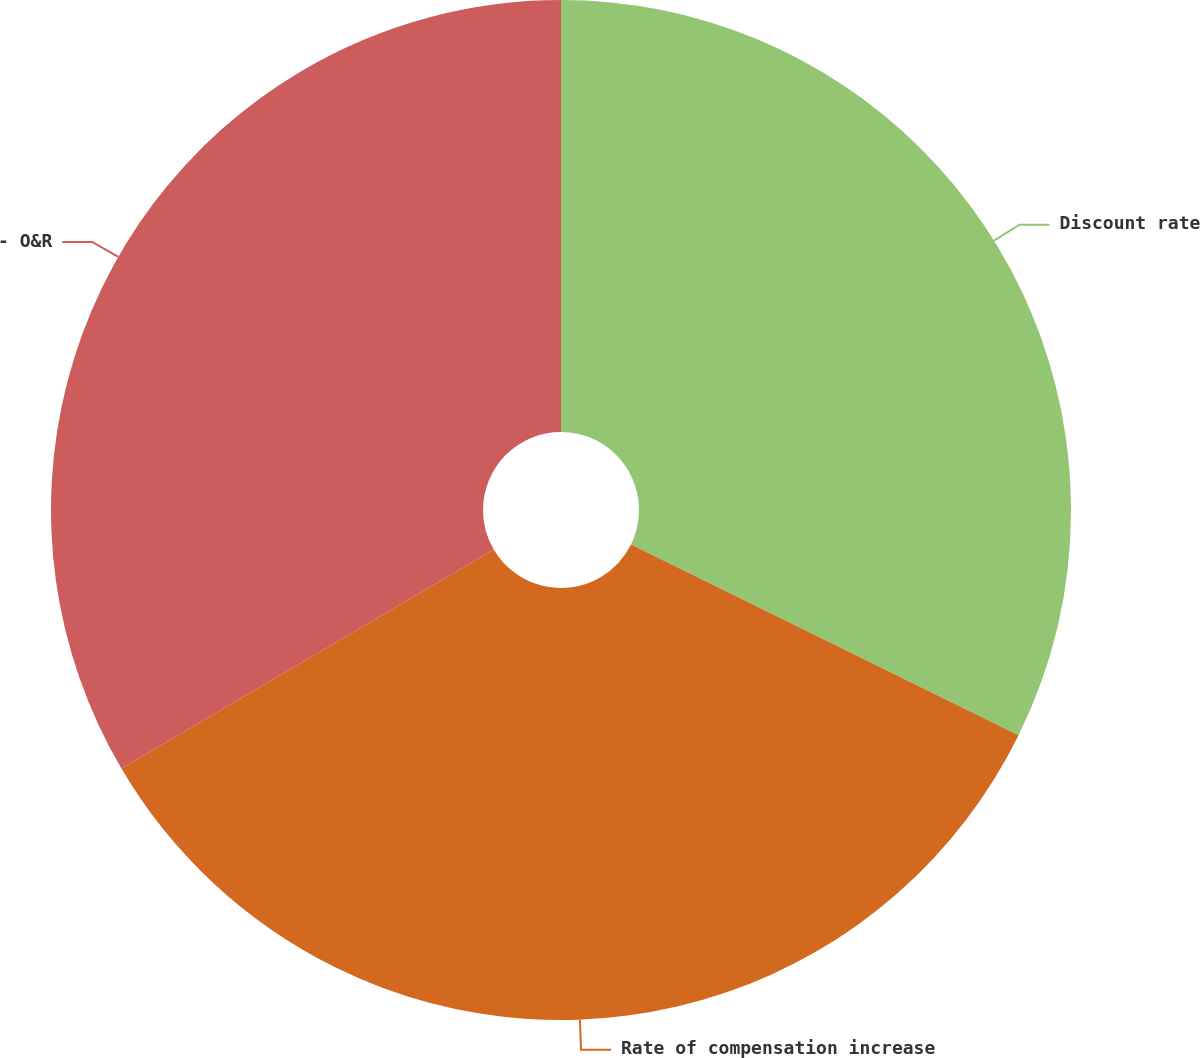<chart> <loc_0><loc_0><loc_500><loc_500><pie_chart><fcel>Discount rate<fcel>Rate of compensation increase<fcel>- O&R<nl><fcel>32.28%<fcel>34.25%<fcel>33.46%<nl></chart> 